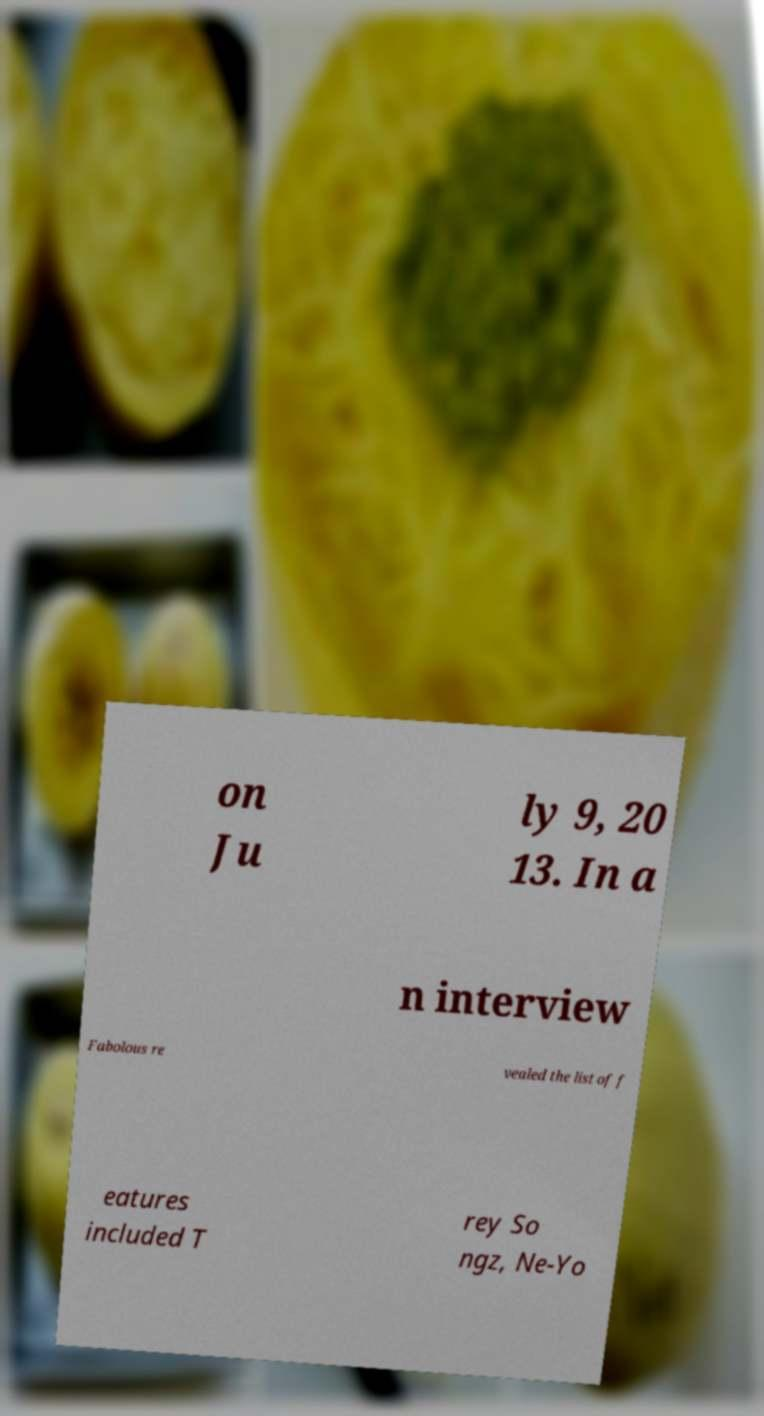Can you accurately transcribe the text from the provided image for me? on Ju ly 9, 20 13. In a n interview Fabolous re vealed the list of f eatures included T rey So ngz, Ne-Yo 